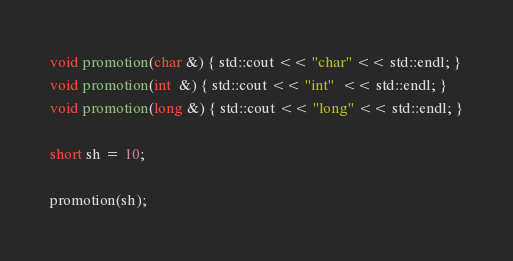Convert code to text. <code><loc_0><loc_0><loc_500><loc_500><_C++_>void promotion(char &) { std::cout << "char" << std::endl; }
void promotion(int  &) { std::cout << "int"  << std::endl; }
void promotion(long &) { std::cout << "long" << std::endl; }

short sh = 10;

promotion(sh); 
</code> 